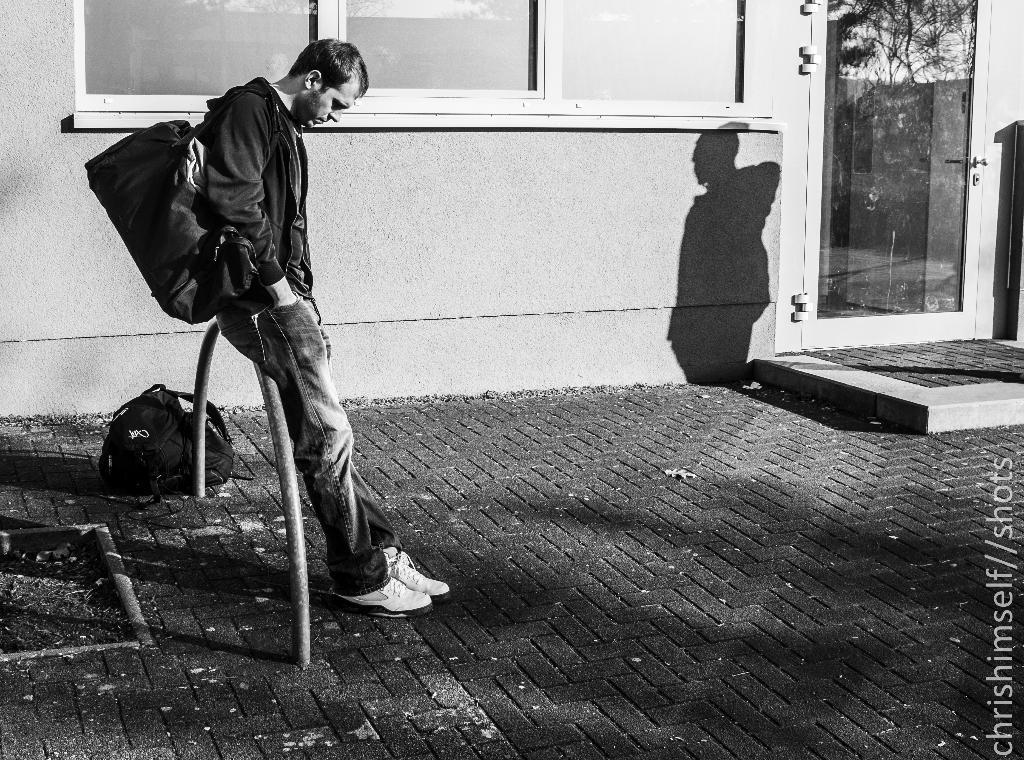Please provide a concise description of this image. As we can see in the image there is wall, window, door, black color bag, a person wearing black color jacket and bag. 